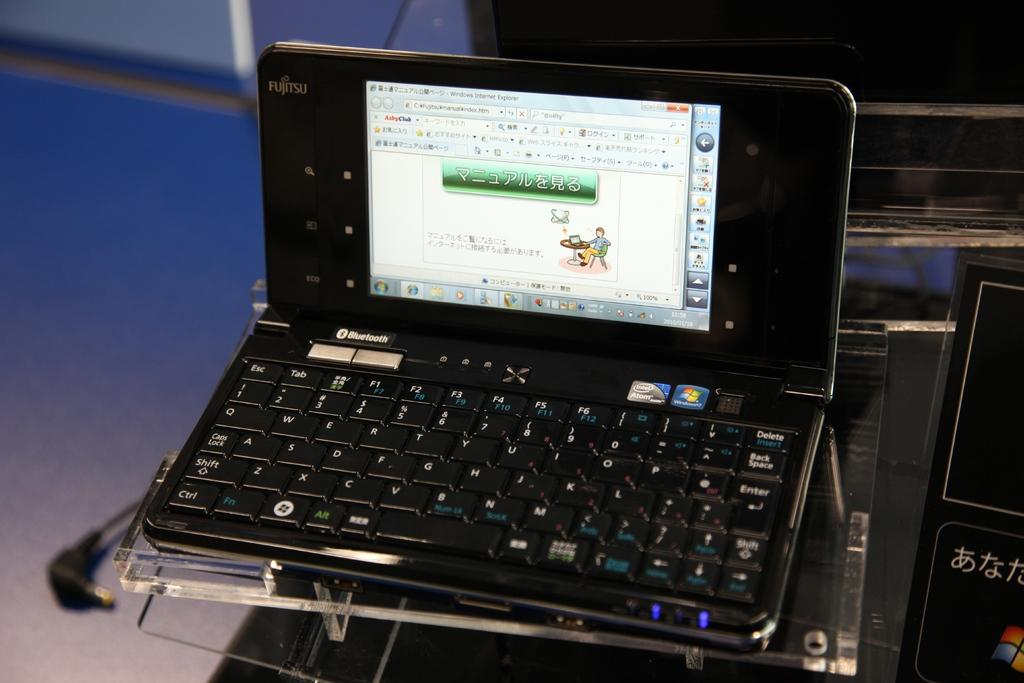<image>
Offer a succinct explanation of the picture presented. a small phone that says bluetooth on it 